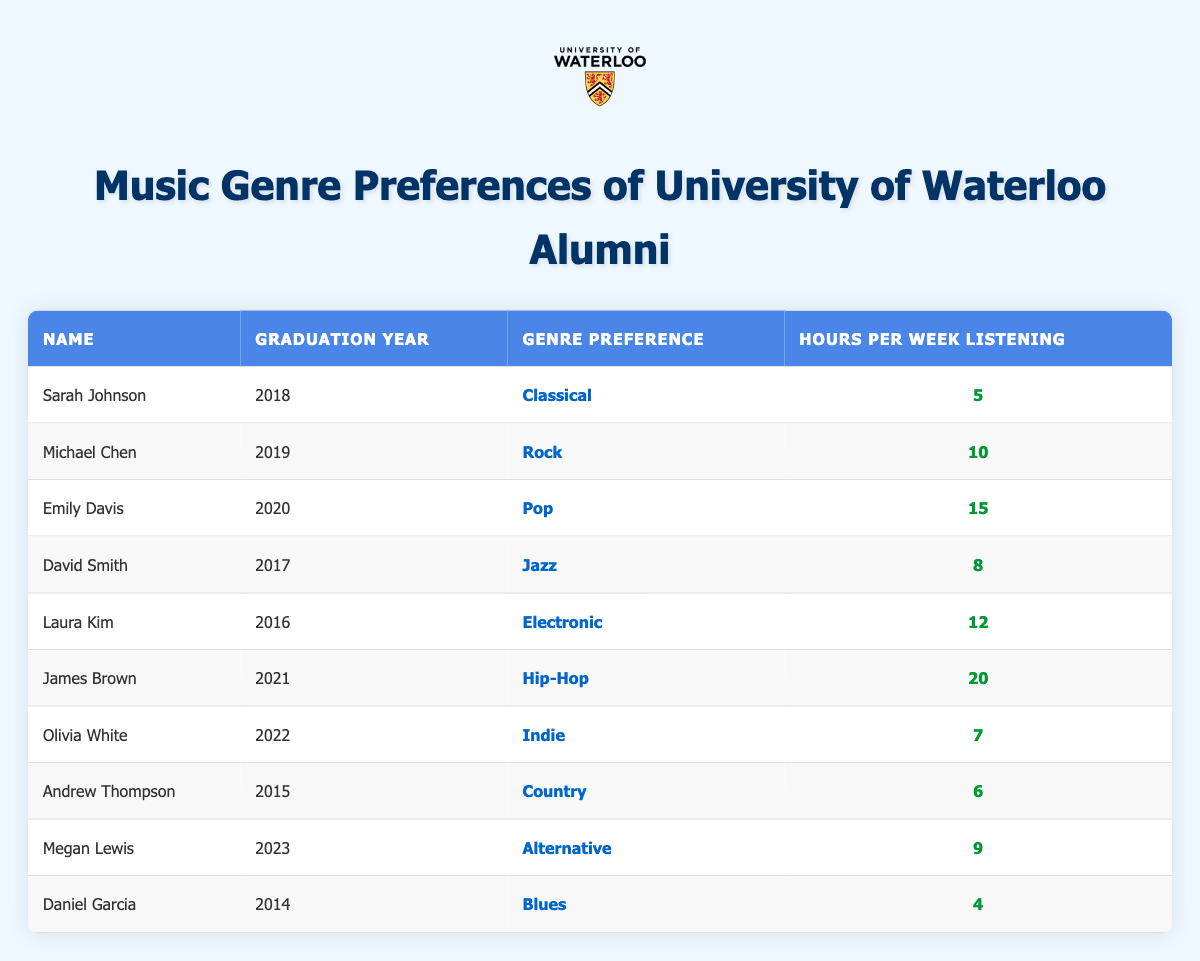What is the genre preference of Emily Davis? According to the table, the genre preference associated with Emily Davis, who graduated in 2020, is listed directly under the "Genre Preference" column.
Answer: Pop How many hours per week does James Brown listen to music? Looking at the row for James Brown, who graduated in 2021, his hours per week listening is found in the "Hours per Week Listening" column, which shows a value of 20.
Answer: 20 What is the total number of hours per week that all alumni spend listening to Hip-Hop and Rock combined? James Brown listens to Hip-Hop for 20 hours and Michael Chen listens to Rock for 10 hours. Adding these together gives 20 + 10 = 30 hours total.
Answer: 30 Is Laura Kim's genre preference listed as Classical? Checking the row for Laura Kim, who graduated in 2016, her genre preference is listed as Electronic, not Classical, hence this statement is false.
Answer: No Which genre has the highest average listening hours among these alumni? First identify the hours for each genre: Classical (5), Rock (10), Pop (15), Jazz (8), Electronic (12), Hip-Hop (20), Indie (7), Country (6), Alternative (9), Blues (4). Summing these and averaging gives (5 + 10 + 15 + 8 + 12 + 20 + 7 + 6 + 9 + 4) = 96 hours across 10 alumni, hence average = 96 / 10 = 9.6. The highest individual is Hip-Hop with 20 hours.
Answer: Hip-Hop Which alumnus listens to the least amount of music per week? Reviewing the table, Daniel Garcia listens to only 4 hours, which is the lowest among all the entries listed in the "Hours per Week Listening" column.
Answer: Daniel Garcia 